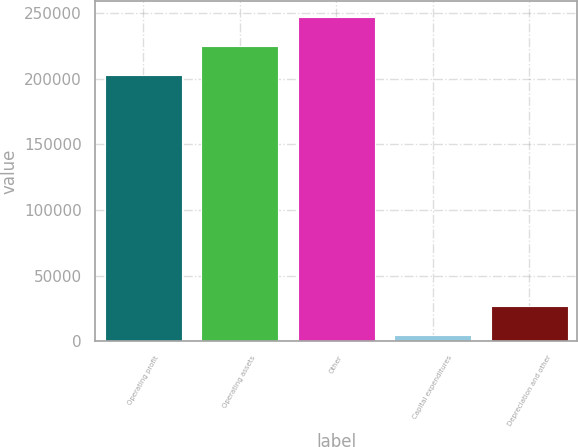Convert chart to OTSL. <chart><loc_0><loc_0><loc_500><loc_500><bar_chart><fcel>Operating profit<fcel>Operating assets<fcel>Other<fcel>Capital expenditures<fcel>Depreciation and other<nl><fcel>203021<fcel>224941<fcel>246860<fcel>4634<fcel>26553.7<nl></chart> 